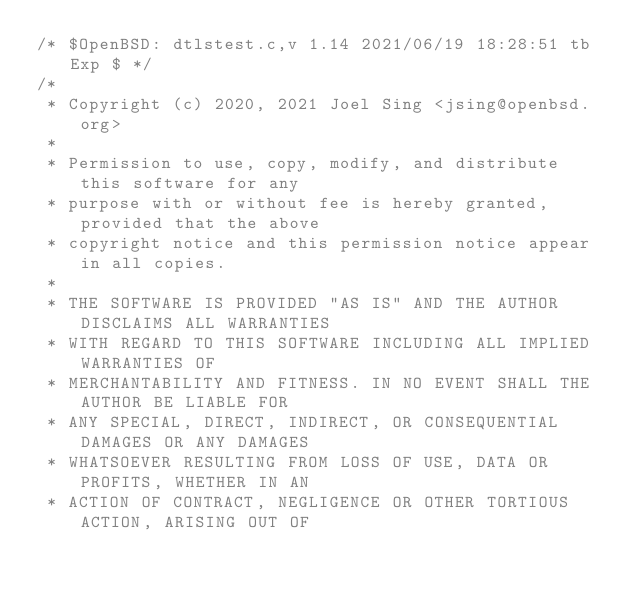<code> <loc_0><loc_0><loc_500><loc_500><_C_>/* $OpenBSD: dtlstest.c,v 1.14 2021/06/19 18:28:51 tb Exp $ */
/*
 * Copyright (c) 2020, 2021 Joel Sing <jsing@openbsd.org>
 *
 * Permission to use, copy, modify, and distribute this software for any
 * purpose with or without fee is hereby granted, provided that the above
 * copyright notice and this permission notice appear in all copies.
 *
 * THE SOFTWARE IS PROVIDED "AS IS" AND THE AUTHOR DISCLAIMS ALL WARRANTIES
 * WITH REGARD TO THIS SOFTWARE INCLUDING ALL IMPLIED WARRANTIES OF
 * MERCHANTABILITY AND FITNESS. IN NO EVENT SHALL THE AUTHOR BE LIABLE FOR
 * ANY SPECIAL, DIRECT, INDIRECT, OR CONSEQUENTIAL DAMAGES OR ANY DAMAGES
 * WHATSOEVER RESULTING FROM LOSS OF USE, DATA OR PROFITS, WHETHER IN AN
 * ACTION OF CONTRACT, NEGLIGENCE OR OTHER TORTIOUS ACTION, ARISING OUT OF</code> 